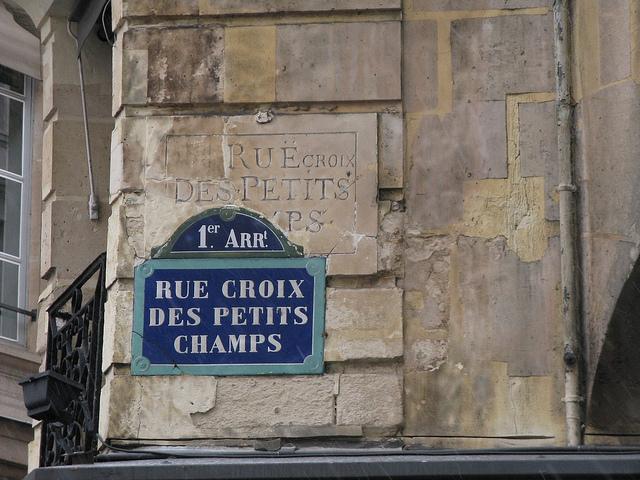Is the wall made of red brick?
Give a very brief answer. No. What color is the lettering of the sign?
Answer briefly. White. What does the street sign translate to in English?
Keep it brief. Unknown. What is the wall made out of?
Give a very brief answer. Stone. What are the words written on this building?
Write a very short answer. Rue croix des petits champs. What is written on the sign?
Quick response, please. Rue croix des petits champs. What color is the sign?
Keep it brief. Blue. 